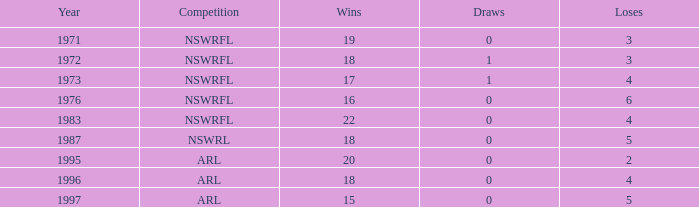What average Loses has Draws less than 0? None. 